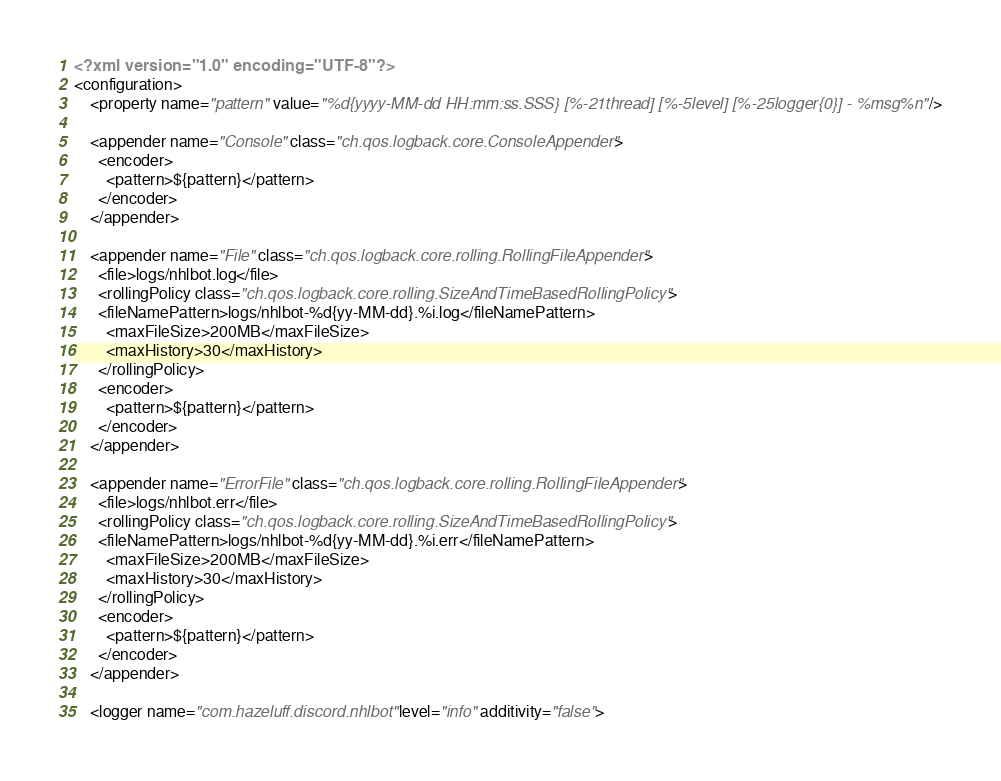<code> <loc_0><loc_0><loc_500><loc_500><_XML_><?xml version="1.0" encoding="UTF-8"?>
<configuration>	
	<property name="pattern" value="%d{yyyy-MM-dd HH:mm:ss.SSS} [%-21thread] [%-5level] [%-25logger{0}] - %msg%n" />

    <appender name="Console" class="ch.qos.logback.core.ConsoleAppender">
      <encoder>
        <pattern>${pattern}</pattern>
      </encoder>
    </appender>
    
    <appender name="File" class="ch.qos.logback.core.rolling.RollingFileAppender">
      <file>logs/nhlbot.log</file>
      <rollingPolicy class="ch.qos.logback.core.rolling.SizeAndTimeBasedRollingPolicy">
      <fileNamePattern>logs/nhlbot-%d{yy-MM-dd}.%i.log</fileNamePattern>
        <maxFileSize>200MB</maxFileSize>    
        <maxHistory>30</maxHistory>
      </rollingPolicy>
      <encoder>
        <pattern>${pattern}</pattern>
      </encoder>
    </appender>
    
    <appender name="ErrorFile" class="ch.qos.logback.core.rolling.RollingFileAppender">
      <file>logs/nhlbot.err</file>
      <rollingPolicy class="ch.qos.logback.core.rolling.SizeAndTimeBasedRollingPolicy">
      <fileNamePattern>logs/nhlbot-%d{yy-MM-dd}.%i.err</fileNamePattern>
        <maxFileSize>200MB</maxFileSize>    
        <maxHistory>30</maxHistory>
      </rollingPolicy>
      <encoder>
        <pattern>${pattern}</pattern>
      </encoder>
    </appender>    
    
    <logger name="com.hazeluff.discord.nhlbot" level="info" additivity="false"></code> 